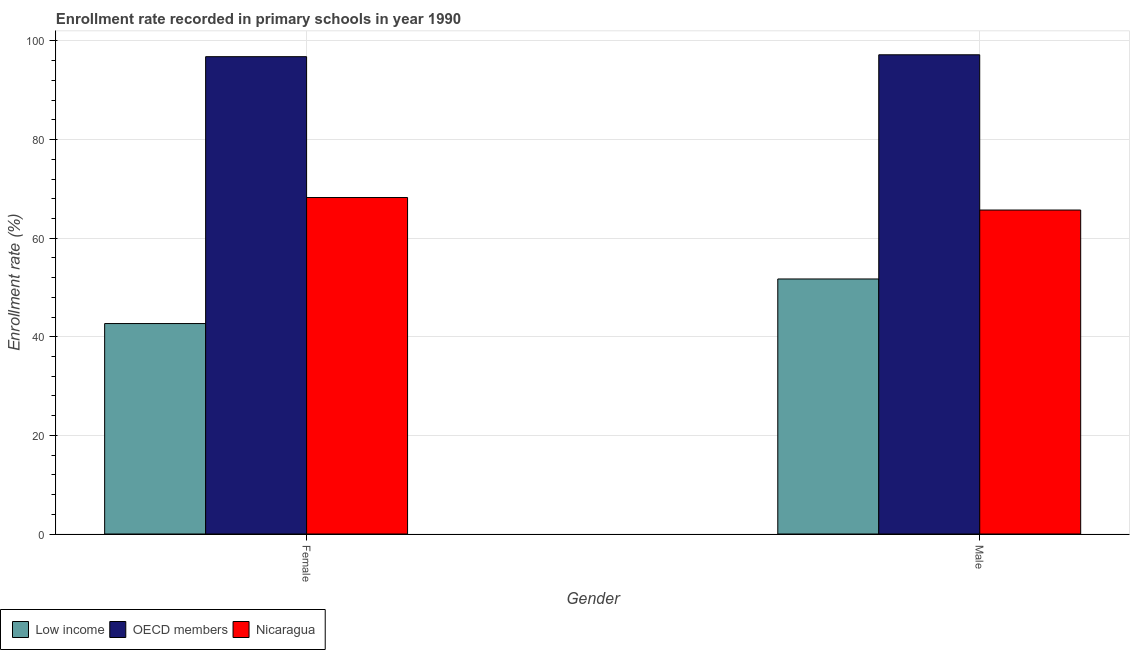How many bars are there on the 2nd tick from the left?
Offer a very short reply. 3. What is the enrollment rate of male students in OECD members?
Keep it short and to the point. 97.19. Across all countries, what is the maximum enrollment rate of female students?
Ensure brevity in your answer.  96.81. Across all countries, what is the minimum enrollment rate of female students?
Your answer should be compact. 42.68. What is the total enrollment rate of female students in the graph?
Give a very brief answer. 207.74. What is the difference between the enrollment rate of male students in OECD members and that in Nicaragua?
Make the answer very short. 31.49. What is the difference between the enrollment rate of male students in OECD members and the enrollment rate of female students in Low income?
Provide a succinct answer. 54.51. What is the average enrollment rate of female students per country?
Keep it short and to the point. 69.25. What is the difference between the enrollment rate of male students and enrollment rate of female students in Low income?
Provide a short and direct response. 9.04. What is the ratio of the enrollment rate of male students in OECD members to that in Low income?
Provide a short and direct response. 1.88. What does the 2nd bar from the right in Female represents?
Your answer should be very brief. OECD members. Are all the bars in the graph horizontal?
Your answer should be very brief. No. How many countries are there in the graph?
Offer a terse response. 3. Are the values on the major ticks of Y-axis written in scientific E-notation?
Make the answer very short. No. How many legend labels are there?
Provide a succinct answer. 3. What is the title of the graph?
Make the answer very short. Enrollment rate recorded in primary schools in year 1990. What is the label or title of the Y-axis?
Offer a very short reply. Enrollment rate (%). What is the Enrollment rate (%) of Low income in Female?
Give a very brief answer. 42.68. What is the Enrollment rate (%) in OECD members in Female?
Give a very brief answer. 96.81. What is the Enrollment rate (%) in Nicaragua in Female?
Your response must be concise. 68.24. What is the Enrollment rate (%) of Low income in Male?
Keep it short and to the point. 51.73. What is the Enrollment rate (%) of OECD members in Male?
Offer a very short reply. 97.19. What is the Enrollment rate (%) in Nicaragua in Male?
Your answer should be compact. 65.71. Across all Gender, what is the maximum Enrollment rate (%) of Low income?
Ensure brevity in your answer.  51.73. Across all Gender, what is the maximum Enrollment rate (%) of OECD members?
Your response must be concise. 97.19. Across all Gender, what is the maximum Enrollment rate (%) in Nicaragua?
Give a very brief answer. 68.24. Across all Gender, what is the minimum Enrollment rate (%) in Low income?
Offer a very short reply. 42.68. Across all Gender, what is the minimum Enrollment rate (%) in OECD members?
Offer a terse response. 96.81. Across all Gender, what is the minimum Enrollment rate (%) of Nicaragua?
Your response must be concise. 65.71. What is the total Enrollment rate (%) in Low income in the graph?
Provide a short and direct response. 94.41. What is the total Enrollment rate (%) in OECD members in the graph?
Provide a succinct answer. 194. What is the total Enrollment rate (%) of Nicaragua in the graph?
Your response must be concise. 133.95. What is the difference between the Enrollment rate (%) in Low income in Female and that in Male?
Provide a short and direct response. -9.04. What is the difference between the Enrollment rate (%) of OECD members in Female and that in Male?
Provide a short and direct response. -0.38. What is the difference between the Enrollment rate (%) in Nicaragua in Female and that in Male?
Make the answer very short. 2.54. What is the difference between the Enrollment rate (%) in Low income in Female and the Enrollment rate (%) in OECD members in Male?
Give a very brief answer. -54.51. What is the difference between the Enrollment rate (%) in Low income in Female and the Enrollment rate (%) in Nicaragua in Male?
Make the answer very short. -23.02. What is the difference between the Enrollment rate (%) of OECD members in Female and the Enrollment rate (%) of Nicaragua in Male?
Give a very brief answer. 31.1. What is the average Enrollment rate (%) of Low income per Gender?
Your answer should be compact. 47.2. What is the average Enrollment rate (%) in OECD members per Gender?
Provide a short and direct response. 97. What is the average Enrollment rate (%) of Nicaragua per Gender?
Offer a very short reply. 66.97. What is the difference between the Enrollment rate (%) of Low income and Enrollment rate (%) of OECD members in Female?
Your response must be concise. -54.13. What is the difference between the Enrollment rate (%) in Low income and Enrollment rate (%) in Nicaragua in Female?
Offer a terse response. -25.56. What is the difference between the Enrollment rate (%) of OECD members and Enrollment rate (%) of Nicaragua in Female?
Give a very brief answer. 28.57. What is the difference between the Enrollment rate (%) in Low income and Enrollment rate (%) in OECD members in Male?
Ensure brevity in your answer.  -45.47. What is the difference between the Enrollment rate (%) in Low income and Enrollment rate (%) in Nicaragua in Male?
Your answer should be compact. -13.98. What is the difference between the Enrollment rate (%) of OECD members and Enrollment rate (%) of Nicaragua in Male?
Your answer should be very brief. 31.49. What is the ratio of the Enrollment rate (%) of Low income in Female to that in Male?
Offer a very short reply. 0.83. What is the ratio of the Enrollment rate (%) in OECD members in Female to that in Male?
Your response must be concise. 1. What is the ratio of the Enrollment rate (%) of Nicaragua in Female to that in Male?
Keep it short and to the point. 1.04. What is the difference between the highest and the second highest Enrollment rate (%) of Low income?
Make the answer very short. 9.04. What is the difference between the highest and the second highest Enrollment rate (%) of OECD members?
Give a very brief answer. 0.38. What is the difference between the highest and the second highest Enrollment rate (%) of Nicaragua?
Provide a short and direct response. 2.54. What is the difference between the highest and the lowest Enrollment rate (%) in Low income?
Provide a succinct answer. 9.04. What is the difference between the highest and the lowest Enrollment rate (%) in OECD members?
Offer a very short reply. 0.38. What is the difference between the highest and the lowest Enrollment rate (%) of Nicaragua?
Your response must be concise. 2.54. 